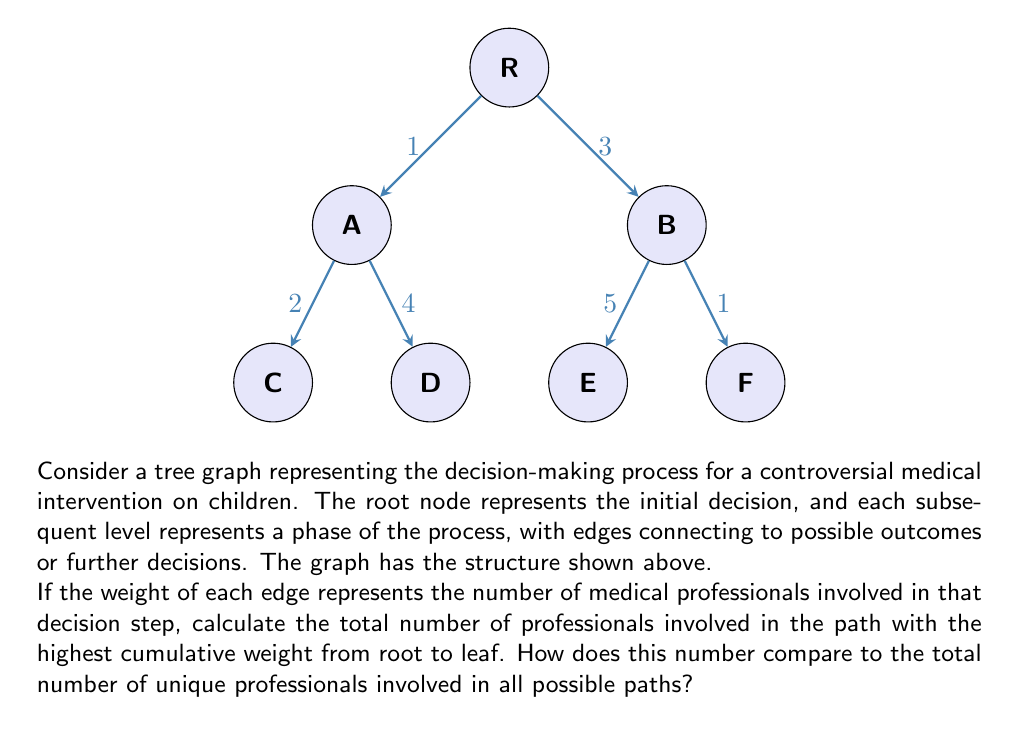Can you solve this math problem? To solve this problem, we need to follow these steps:

1. Identify all paths from root to leaf:
   Path 1: R -> A -> C
   Path 2: R -> A -> D
   Path 3: R -> B -> E
   Path 4: R -> B -> F

2. Calculate the cumulative weight for each path:
   Path 1: 1 + 2 = 3
   Path 2: 1 + 4 = 5
   Path 3: 3 + 5 = 8
   Path 4: 3 + 1 = 4

3. Identify the path with the highest cumulative weight:
   Path 3 (R -> B -> E) has the highest weight of 8.

4. Calculate the total number of unique professionals:
   Sum of all edge weights: 1 + 3 + 2 + 4 + 5 + 1 = 16

The path with the highest cumulative weight involves 8 professionals, while the total number of unique professionals involved in all possible paths is 16.

To compare these numbers:

$$\frac{\text{Professionals in highest weight path}}{\text{Total unique professionals}} = \frac{8}{16} = \frac{1}{2} = 0.5$$

This means that the path with the highest involvement of professionals represents 50% of all unique professionals involved in the entire decision-making process.

This analysis reveals that half of the total professional involvement is concentrated in a single decision path, which could raise concerns about the distribution of expertise and potential biases in the decision-making process for this medical intervention on children.
Answer: 8 professionals; 50% of total 